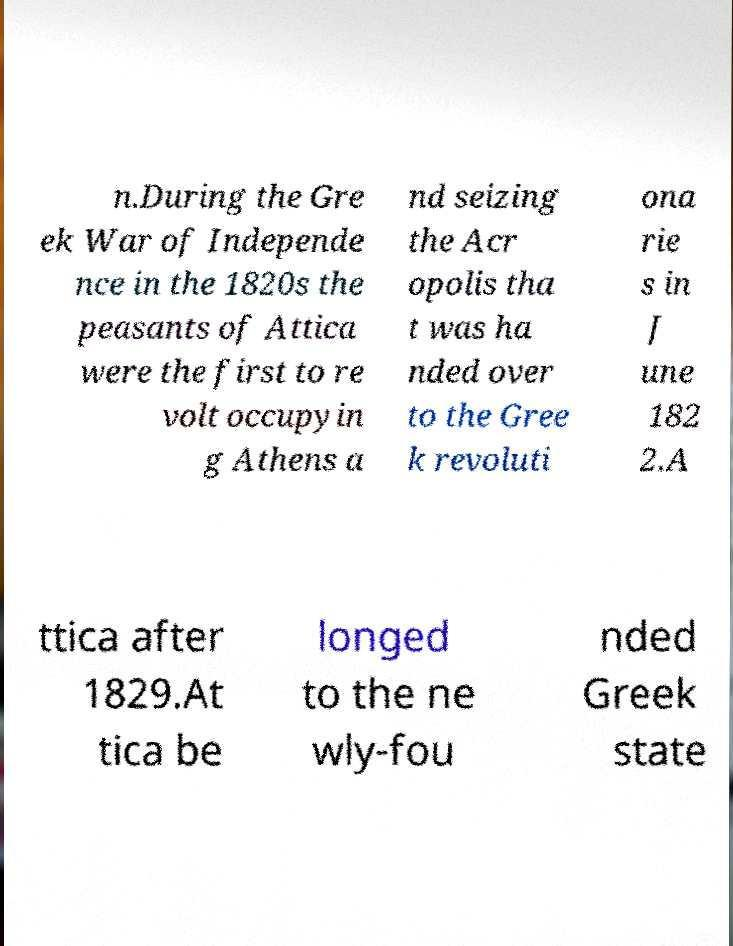Please read and relay the text visible in this image. What does it say? n.During the Gre ek War of Independe nce in the 1820s the peasants of Attica were the first to re volt occupyin g Athens a nd seizing the Acr opolis tha t was ha nded over to the Gree k revoluti ona rie s in J une 182 2.A ttica after 1829.At tica be longed to the ne wly-fou nded Greek state 